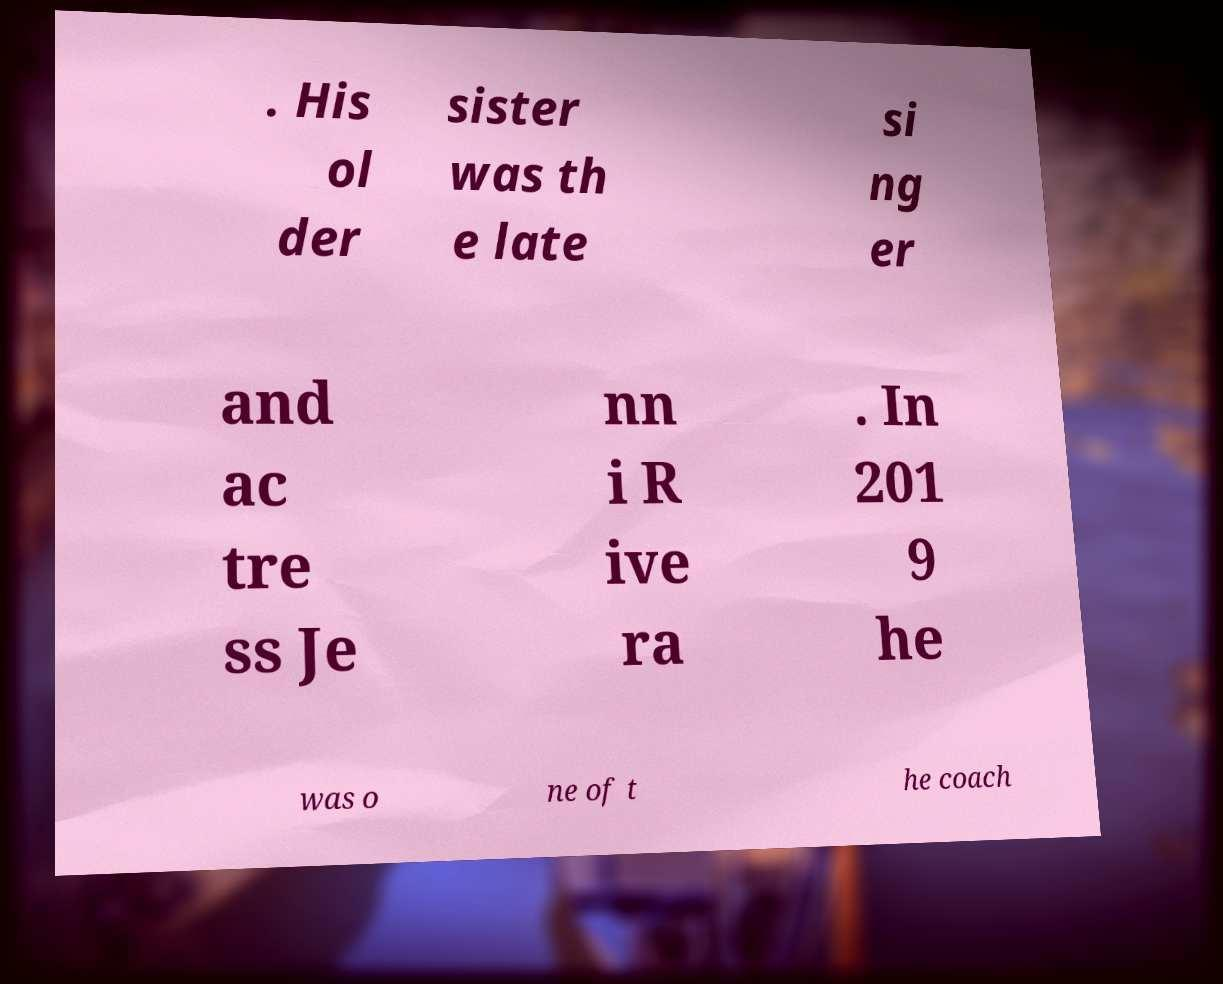There's text embedded in this image that I need extracted. Can you transcribe it verbatim? . His ol der sister was th e late si ng er and ac tre ss Je nn i R ive ra . In 201 9 he was o ne of t he coach 